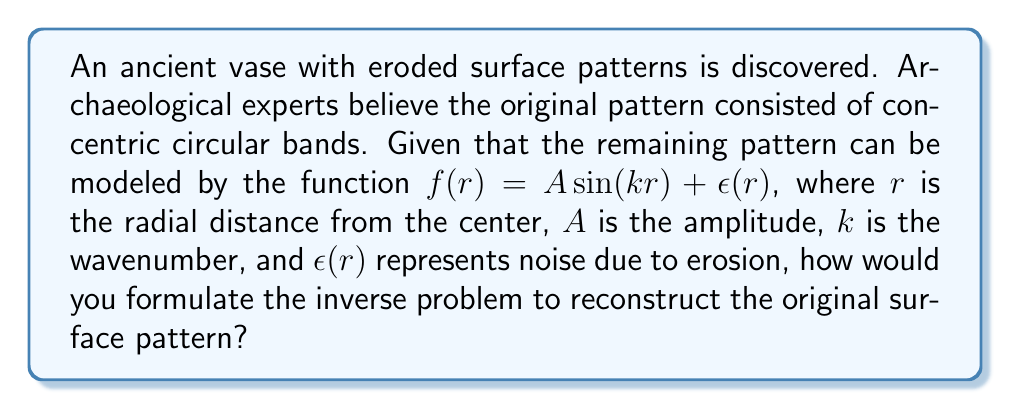Help me with this question. To reconstruct the original surface pattern of the eroded ancient vase, we need to formulate an inverse problem. Here's a step-by-step approach:

1. Define the forward problem:
   The forward problem is given by the model $f(r) = A \sin(kr) + \epsilon(r)$

2. Identify the known and unknown parameters:
   - Known: Measured data $f(r)$ at various points on the vase surface
   - Unknown: Amplitude $A$ and wavenumber $k$

3. Formulate the inverse problem:
   Find $A$ and $k$ that minimize the difference between the measured data and the model prediction.

4. Define the objective function:
   $$J(A,k) = \sum_{i=1}^N [f(r_i) - A \sin(kr_i)]^2$$
   where $N$ is the number of measurement points.

5. Set up the optimization problem:
   $$\min_{A,k} J(A,k)$$

6. Choose an appropriate optimization method:
   For this problem, a non-linear least squares method like Levenberg-Marquardt algorithm would be suitable.

7. Implement regularization:
   To handle the noise $\epsilon(r)$, add a regularization term to the objective function:
   $$J_{reg}(A,k) = \sum_{i=1}^N [f(r_i) - A \sin(kr_i)]^2 + \lambda (A^2 + k^2)$$
   where $\lambda$ is the regularization parameter.

8. Solve the regularized optimization problem:
   $$\min_{A,k} J_{reg}(A,k)$$

By solving this inverse problem, we can estimate the amplitude $A$ and wavenumber $k$ of the original surface pattern, effectively reconstructing the concentric circular bands on the ancient vase.
Answer: Minimize $J_{reg}(A,k) = \sum_{i=1}^N [f(r_i) - A \sin(kr_i)]^2 + \lambda (A^2 + k^2)$ w.r.t. $A$ and $k$ 